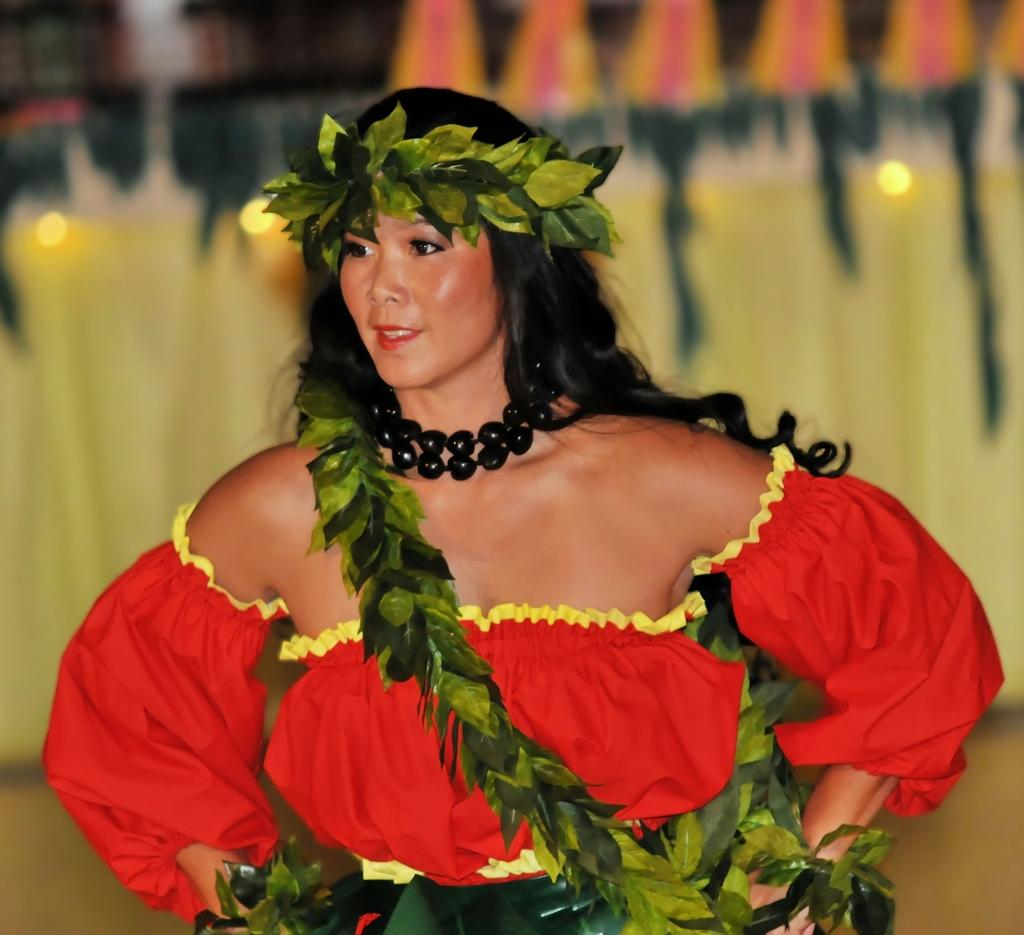Who is present in the image? There is a woman in the image. What is the woman wearing? The woman is wearing a red dress and a black necklace. What type of grass can be seen growing near the coast in the image? There is no grass, coast, or club present in the image; it features a woman wearing a red dress and a black necklace. 